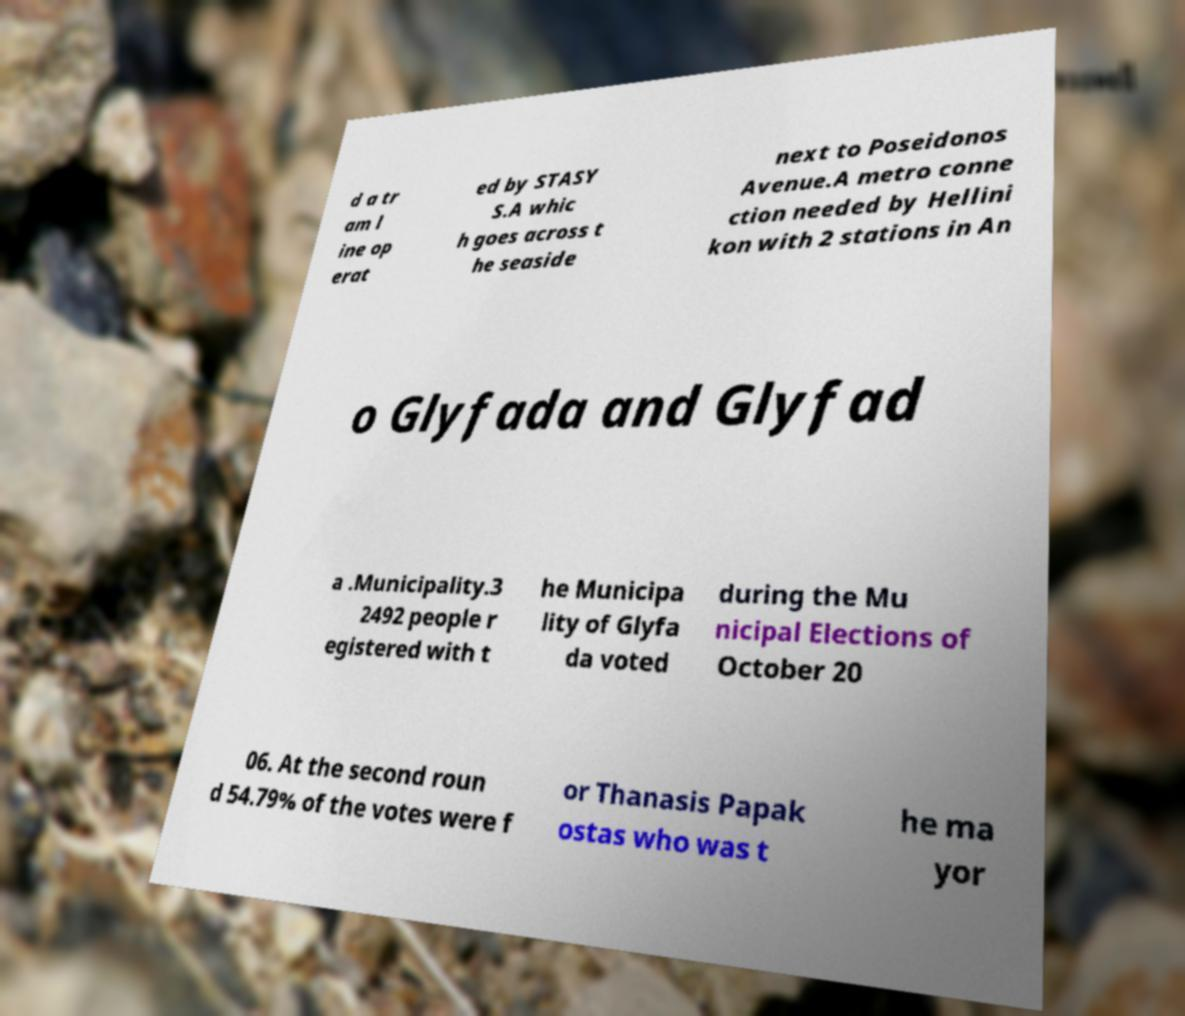Could you extract and type out the text from this image? d a tr am l ine op erat ed by STASY S.A whic h goes across t he seaside next to Poseidonos Avenue.A metro conne ction needed by Hellini kon with 2 stations in An o Glyfada and Glyfad a .Municipality.3 2492 people r egistered with t he Municipa lity of Glyfa da voted during the Mu nicipal Elections of October 20 06. At the second roun d 54.79% of the votes were f or Thanasis Papak ostas who was t he ma yor 